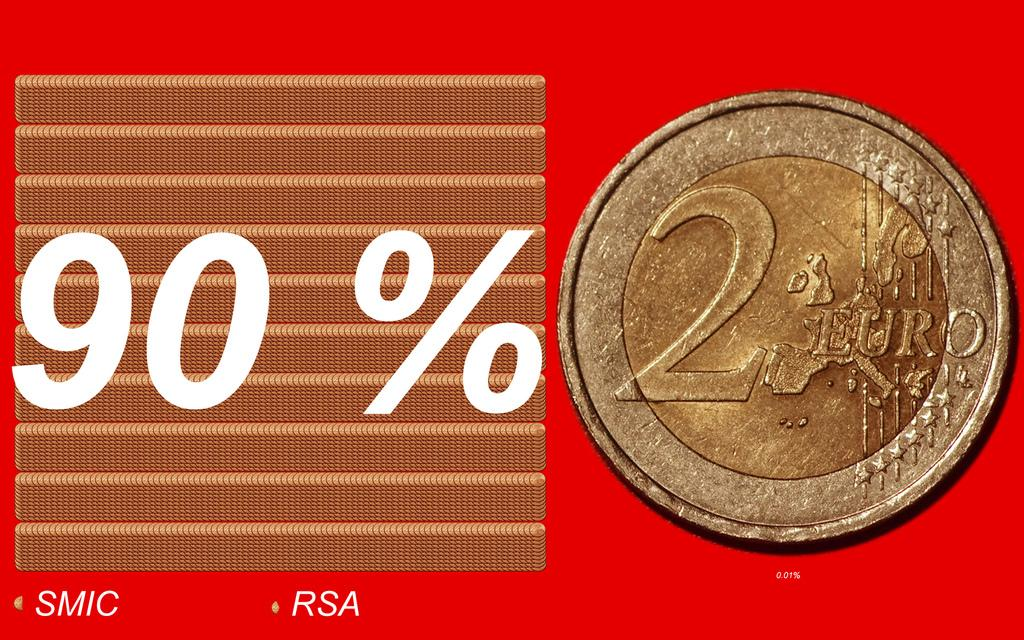<image>
Provide a brief description of the given image. a 90 percent sitting next to a coin with the value of 2 